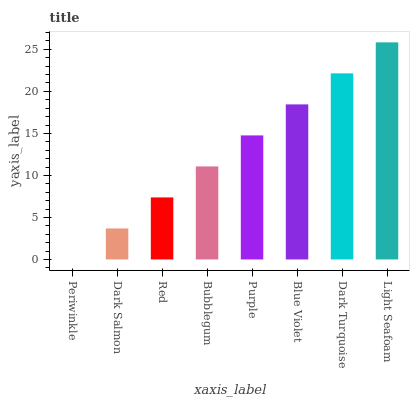Is Periwinkle the minimum?
Answer yes or no. Yes. Is Light Seafoam the maximum?
Answer yes or no. Yes. Is Dark Salmon the minimum?
Answer yes or no. No. Is Dark Salmon the maximum?
Answer yes or no. No. Is Dark Salmon greater than Periwinkle?
Answer yes or no. Yes. Is Periwinkle less than Dark Salmon?
Answer yes or no. Yes. Is Periwinkle greater than Dark Salmon?
Answer yes or no. No. Is Dark Salmon less than Periwinkle?
Answer yes or no. No. Is Purple the high median?
Answer yes or no. Yes. Is Bubblegum the low median?
Answer yes or no. Yes. Is Light Seafoam the high median?
Answer yes or no. No. Is Dark Salmon the low median?
Answer yes or no. No. 